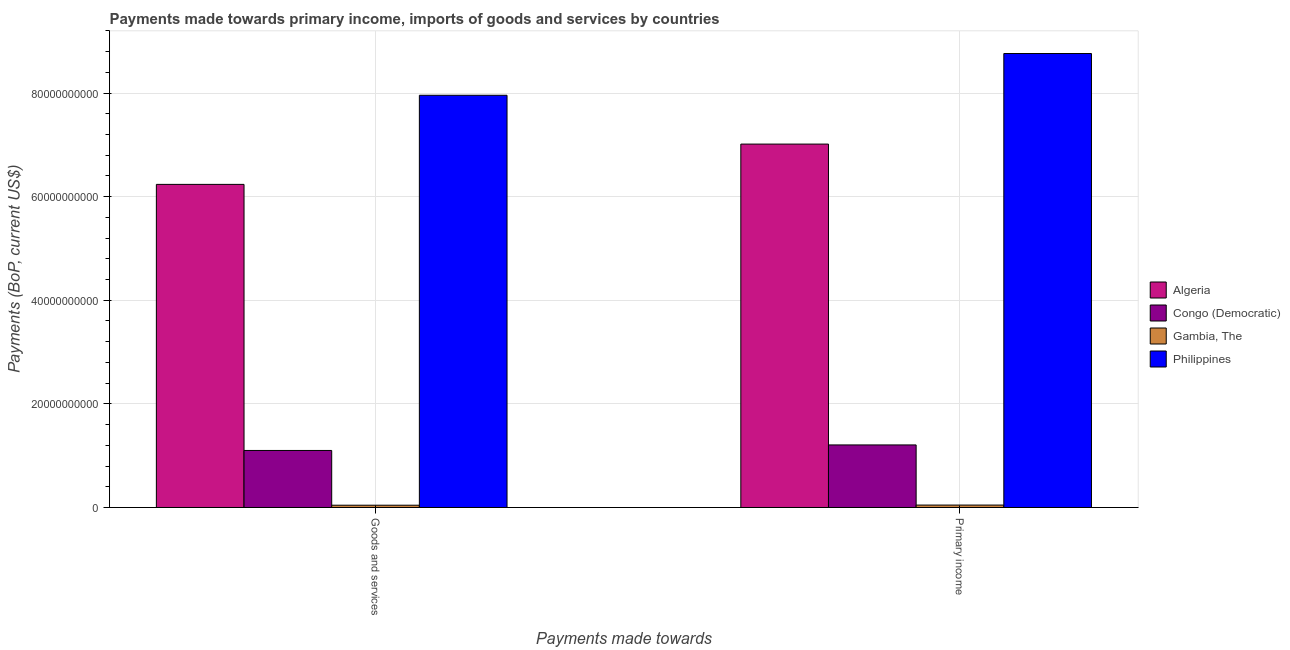How many different coloured bars are there?
Provide a short and direct response. 4. Are the number of bars on each tick of the X-axis equal?
Offer a very short reply. Yes. How many bars are there on the 1st tick from the left?
Give a very brief answer. 4. What is the label of the 1st group of bars from the left?
Your response must be concise. Goods and services. What is the payments made towards goods and services in Algeria?
Ensure brevity in your answer.  6.24e+1. Across all countries, what is the maximum payments made towards primary income?
Ensure brevity in your answer.  8.76e+1. Across all countries, what is the minimum payments made towards goods and services?
Your answer should be very brief. 4.39e+08. In which country was the payments made towards primary income minimum?
Keep it short and to the point. Gambia, The. What is the total payments made towards primary income in the graph?
Provide a succinct answer. 1.70e+11. What is the difference between the payments made towards primary income in Philippines and that in Congo (Democratic)?
Your response must be concise. 7.56e+1. What is the difference between the payments made towards primary income in Gambia, The and the payments made towards goods and services in Philippines?
Your response must be concise. -7.91e+1. What is the average payments made towards goods and services per country?
Provide a short and direct response. 3.83e+1. What is the difference between the payments made towards primary income and payments made towards goods and services in Gambia, The?
Make the answer very short. 2.85e+07. In how many countries, is the payments made towards goods and services greater than 52000000000 US$?
Give a very brief answer. 2. What is the ratio of the payments made towards primary income in Congo (Democratic) to that in Algeria?
Provide a short and direct response. 0.17. In how many countries, is the payments made towards primary income greater than the average payments made towards primary income taken over all countries?
Your answer should be compact. 2. What does the 1st bar from the left in Goods and services represents?
Your response must be concise. Algeria. What does the 3rd bar from the right in Primary income represents?
Offer a terse response. Congo (Democratic). How many bars are there?
Your answer should be compact. 8. What is the difference between two consecutive major ticks on the Y-axis?
Offer a terse response. 2.00e+1. Does the graph contain any zero values?
Your answer should be very brief. No. Does the graph contain grids?
Your answer should be compact. Yes. What is the title of the graph?
Offer a very short reply. Payments made towards primary income, imports of goods and services by countries. What is the label or title of the X-axis?
Your answer should be very brief. Payments made towards. What is the label or title of the Y-axis?
Ensure brevity in your answer.  Payments (BoP, current US$). What is the Payments (BoP, current US$) in Algeria in Goods and services?
Make the answer very short. 6.24e+1. What is the Payments (BoP, current US$) in Congo (Democratic) in Goods and services?
Keep it short and to the point. 1.10e+1. What is the Payments (BoP, current US$) of Gambia, The in Goods and services?
Offer a very short reply. 4.39e+08. What is the Payments (BoP, current US$) of Philippines in Goods and services?
Keep it short and to the point. 7.96e+1. What is the Payments (BoP, current US$) of Algeria in Primary income?
Your answer should be very brief. 7.02e+1. What is the Payments (BoP, current US$) of Congo (Democratic) in Primary income?
Offer a terse response. 1.21e+1. What is the Payments (BoP, current US$) of Gambia, The in Primary income?
Your response must be concise. 4.68e+08. What is the Payments (BoP, current US$) in Philippines in Primary income?
Your response must be concise. 8.76e+1. Across all Payments made towards, what is the maximum Payments (BoP, current US$) in Algeria?
Ensure brevity in your answer.  7.02e+1. Across all Payments made towards, what is the maximum Payments (BoP, current US$) in Congo (Democratic)?
Make the answer very short. 1.21e+1. Across all Payments made towards, what is the maximum Payments (BoP, current US$) of Gambia, The?
Offer a very short reply. 4.68e+08. Across all Payments made towards, what is the maximum Payments (BoP, current US$) of Philippines?
Offer a very short reply. 8.76e+1. Across all Payments made towards, what is the minimum Payments (BoP, current US$) in Algeria?
Give a very brief answer. 6.24e+1. Across all Payments made towards, what is the minimum Payments (BoP, current US$) of Congo (Democratic)?
Keep it short and to the point. 1.10e+1. Across all Payments made towards, what is the minimum Payments (BoP, current US$) of Gambia, The?
Your answer should be compact. 4.39e+08. Across all Payments made towards, what is the minimum Payments (BoP, current US$) of Philippines?
Ensure brevity in your answer.  7.96e+1. What is the total Payments (BoP, current US$) of Algeria in the graph?
Your answer should be compact. 1.33e+11. What is the total Payments (BoP, current US$) of Congo (Democratic) in the graph?
Make the answer very short. 2.31e+1. What is the total Payments (BoP, current US$) of Gambia, The in the graph?
Make the answer very short. 9.07e+08. What is the total Payments (BoP, current US$) of Philippines in the graph?
Your answer should be compact. 1.67e+11. What is the difference between the Payments (BoP, current US$) of Algeria in Goods and services and that in Primary income?
Offer a very short reply. -7.78e+09. What is the difference between the Payments (BoP, current US$) of Congo (Democratic) in Goods and services and that in Primary income?
Provide a succinct answer. -1.07e+09. What is the difference between the Payments (BoP, current US$) of Gambia, The in Goods and services and that in Primary income?
Offer a terse response. -2.85e+07. What is the difference between the Payments (BoP, current US$) in Philippines in Goods and services and that in Primary income?
Keep it short and to the point. -8.06e+09. What is the difference between the Payments (BoP, current US$) of Algeria in Goods and services and the Payments (BoP, current US$) of Congo (Democratic) in Primary income?
Ensure brevity in your answer.  5.03e+1. What is the difference between the Payments (BoP, current US$) in Algeria in Goods and services and the Payments (BoP, current US$) in Gambia, The in Primary income?
Your response must be concise. 6.19e+1. What is the difference between the Payments (BoP, current US$) in Algeria in Goods and services and the Payments (BoP, current US$) in Philippines in Primary income?
Your answer should be very brief. -2.53e+1. What is the difference between the Payments (BoP, current US$) of Congo (Democratic) in Goods and services and the Payments (BoP, current US$) of Gambia, The in Primary income?
Offer a very short reply. 1.05e+1. What is the difference between the Payments (BoP, current US$) in Congo (Democratic) in Goods and services and the Payments (BoP, current US$) in Philippines in Primary income?
Provide a succinct answer. -7.66e+1. What is the difference between the Payments (BoP, current US$) of Gambia, The in Goods and services and the Payments (BoP, current US$) of Philippines in Primary income?
Give a very brief answer. -8.72e+1. What is the average Payments (BoP, current US$) of Algeria per Payments made towards?
Your answer should be compact. 6.63e+1. What is the average Payments (BoP, current US$) of Congo (Democratic) per Payments made towards?
Your answer should be very brief. 1.15e+1. What is the average Payments (BoP, current US$) of Gambia, The per Payments made towards?
Your answer should be compact. 4.53e+08. What is the average Payments (BoP, current US$) of Philippines per Payments made towards?
Make the answer very short. 8.36e+1. What is the difference between the Payments (BoP, current US$) in Algeria and Payments (BoP, current US$) in Congo (Democratic) in Goods and services?
Provide a short and direct response. 5.14e+1. What is the difference between the Payments (BoP, current US$) of Algeria and Payments (BoP, current US$) of Gambia, The in Goods and services?
Your answer should be compact. 6.19e+1. What is the difference between the Payments (BoP, current US$) in Algeria and Payments (BoP, current US$) in Philippines in Goods and services?
Give a very brief answer. -1.72e+1. What is the difference between the Payments (BoP, current US$) of Congo (Democratic) and Payments (BoP, current US$) of Gambia, The in Goods and services?
Provide a short and direct response. 1.06e+1. What is the difference between the Payments (BoP, current US$) in Congo (Democratic) and Payments (BoP, current US$) in Philippines in Goods and services?
Provide a succinct answer. -6.86e+1. What is the difference between the Payments (BoP, current US$) in Gambia, The and Payments (BoP, current US$) in Philippines in Goods and services?
Offer a terse response. -7.91e+1. What is the difference between the Payments (BoP, current US$) of Algeria and Payments (BoP, current US$) of Congo (Democratic) in Primary income?
Provide a succinct answer. 5.81e+1. What is the difference between the Payments (BoP, current US$) of Algeria and Payments (BoP, current US$) of Gambia, The in Primary income?
Ensure brevity in your answer.  6.97e+1. What is the difference between the Payments (BoP, current US$) in Algeria and Payments (BoP, current US$) in Philippines in Primary income?
Offer a very short reply. -1.75e+1. What is the difference between the Payments (BoP, current US$) in Congo (Democratic) and Payments (BoP, current US$) in Gambia, The in Primary income?
Keep it short and to the point. 1.16e+1. What is the difference between the Payments (BoP, current US$) in Congo (Democratic) and Payments (BoP, current US$) in Philippines in Primary income?
Provide a succinct answer. -7.56e+1. What is the difference between the Payments (BoP, current US$) of Gambia, The and Payments (BoP, current US$) of Philippines in Primary income?
Offer a terse response. -8.72e+1. What is the ratio of the Payments (BoP, current US$) of Algeria in Goods and services to that in Primary income?
Provide a succinct answer. 0.89. What is the ratio of the Payments (BoP, current US$) in Congo (Democratic) in Goods and services to that in Primary income?
Offer a very short reply. 0.91. What is the ratio of the Payments (BoP, current US$) in Gambia, The in Goods and services to that in Primary income?
Ensure brevity in your answer.  0.94. What is the ratio of the Payments (BoP, current US$) of Philippines in Goods and services to that in Primary income?
Make the answer very short. 0.91. What is the difference between the highest and the second highest Payments (BoP, current US$) in Algeria?
Provide a succinct answer. 7.78e+09. What is the difference between the highest and the second highest Payments (BoP, current US$) of Congo (Democratic)?
Make the answer very short. 1.07e+09. What is the difference between the highest and the second highest Payments (BoP, current US$) of Gambia, The?
Your answer should be very brief. 2.85e+07. What is the difference between the highest and the second highest Payments (BoP, current US$) in Philippines?
Ensure brevity in your answer.  8.06e+09. What is the difference between the highest and the lowest Payments (BoP, current US$) in Algeria?
Provide a succinct answer. 7.78e+09. What is the difference between the highest and the lowest Payments (BoP, current US$) in Congo (Democratic)?
Your answer should be very brief. 1.07e+09. What is the difference between the highest and the lowest Payments (BoP, current US$) of Gambia, The?
Provide a succinct answer. 2.85e+07. What is the difference between the highest and the lowest Payments (BoP, current US$) in Philippines?
Your answer should be compact. 8.06e+09. 